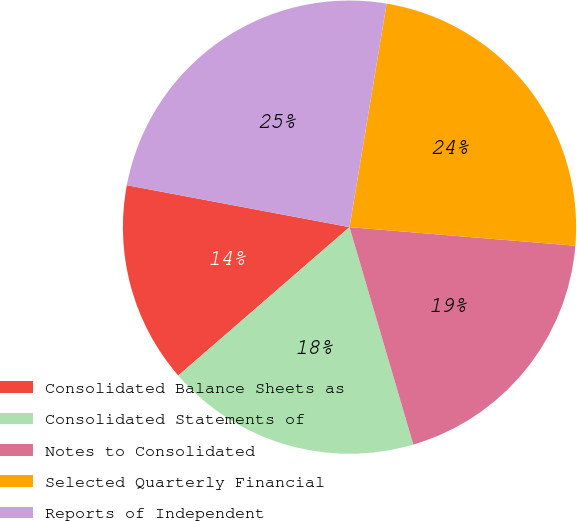<chart> <loc_0><loc_0><loc_500><loc_500><pie_chart><fcel>Consolidated Balance Sheets as<fcel>Consolidated Statements of<fcel>Notes to Consolidated<fcel>Selected Quarterly Financial<fcel>Reports of Independent<nl><fcel>14.33%<fcel>18.18%<fcel>19.15%<fcel>23.69%<fcel>24.66%<nl></chart> 